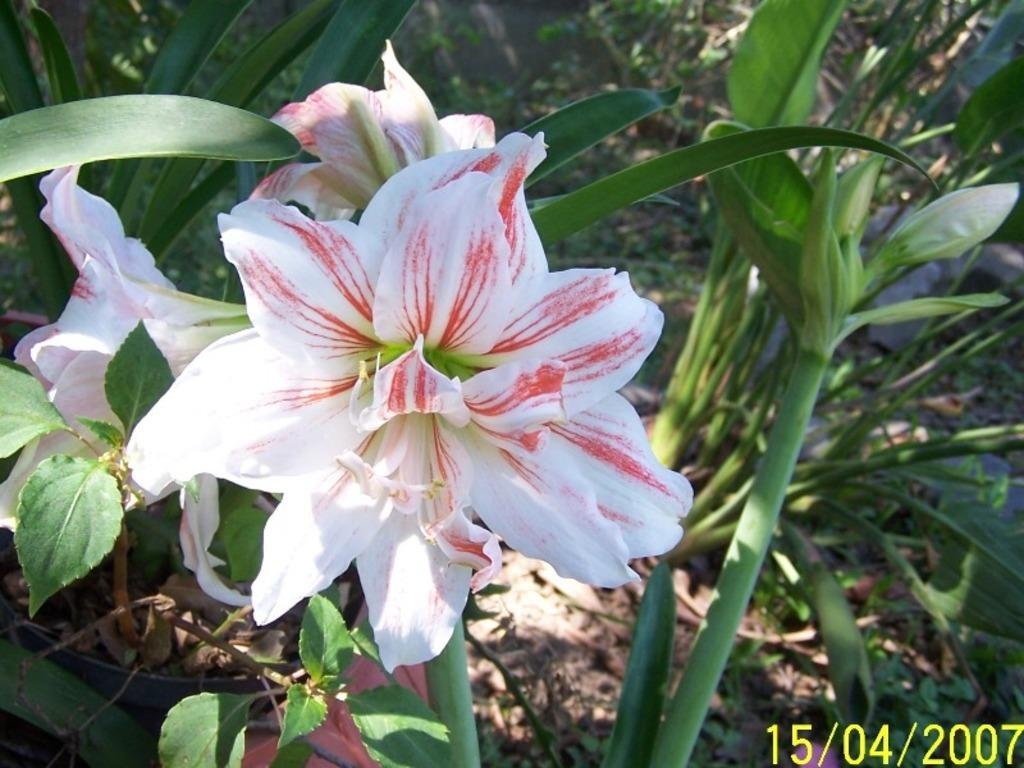What type of living organisms can be seen in the image? Flower plants can be seen in the image. Can you describe the plants in the image? The plants in the image are flower plants, which typically have flowers and leaves. What might be the purpose of these plants in the image? The purpose of these plants in the image is not explicitly stated, but they could be for decoration, gardening, or other purposes. What type of sheet is being used to bake the plants in the image? There is no sheet or baking involved in the image; it features flower plants. What type of leaf can be seen on the oven in the image? There is no oven or leaf present in the image; it features flower plants. 